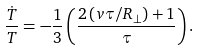<formula> <loc_0><loc_0><loc_500><loc_500>\frac { \dot { T } } { T } = - \frac { 1 } { 3 } \left ( \frac { 2 \, ( v \tau / R _ { \perp } ) + 1 } { \tau } \right ) .</formula> 